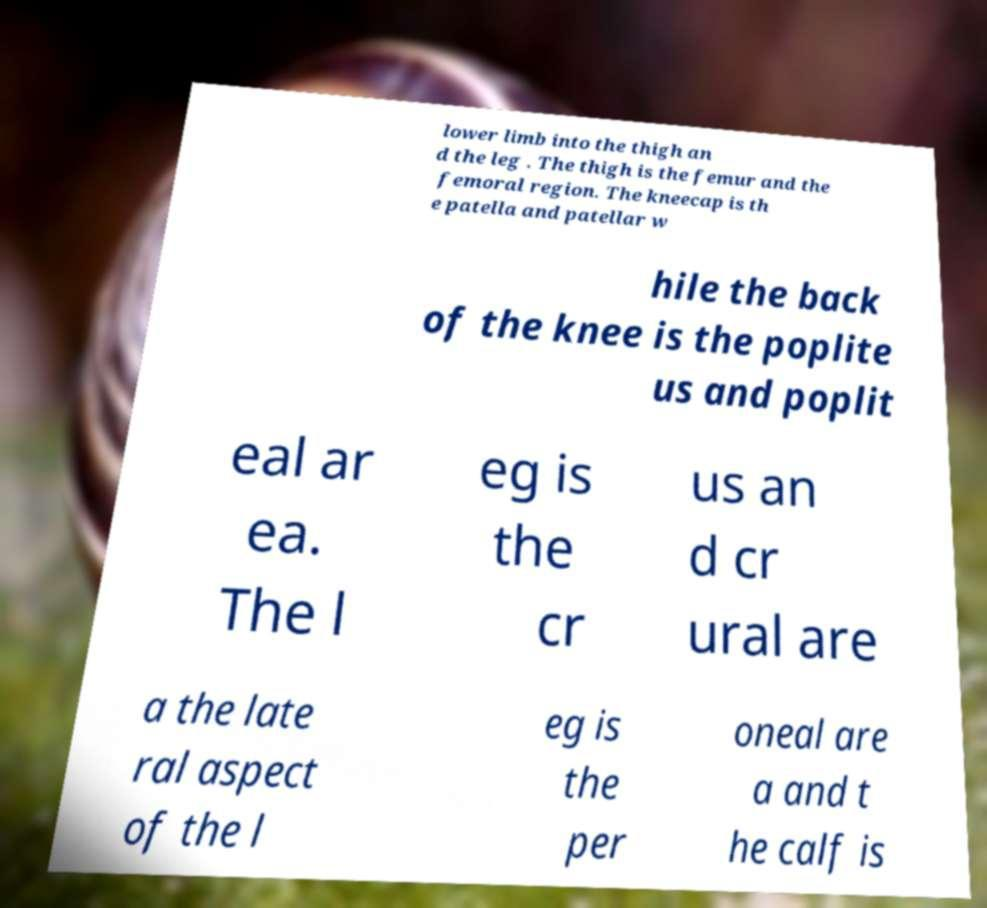Can you accurately transcribe the text from the provided image for me? lower limb into the thigh an d the leg . The thigh is the femur and the femoral region. The kneecap is th e patella and patellar w hile the back of the knee is the poplite us and poplit eal ar ea. The l eg is the cr us an d cr ural are a the late ral aspect of the l eg is the per oneal are a and t he calf is 